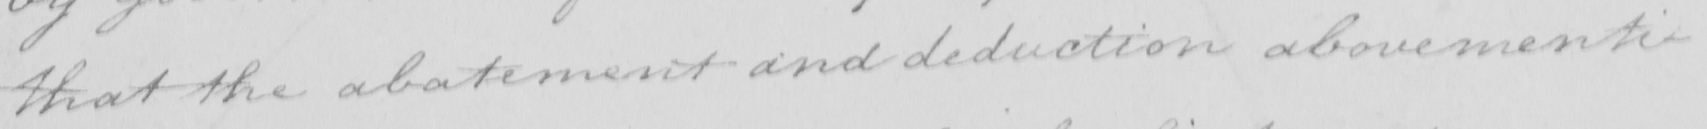What does this handwritten line say? that the abatement and deduction abovementi- 